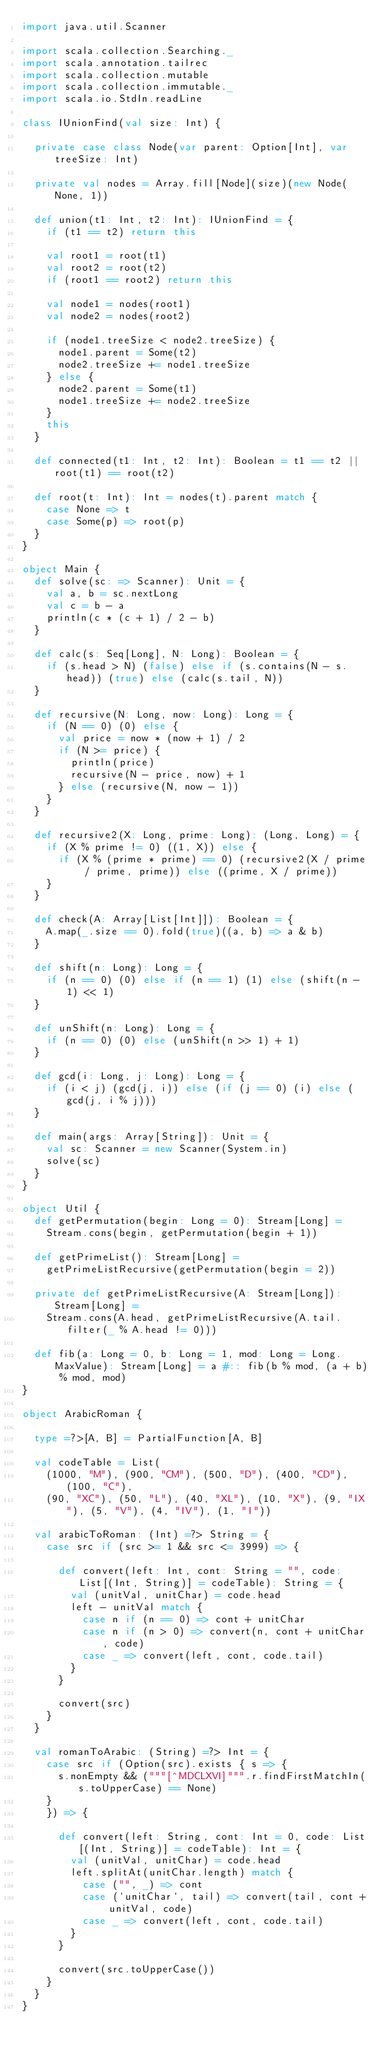<code> <loc_0><loc_0><loc_500><loc_500><_Scala_>import java.util.Scanner

import scala.collection.Searching._
import scala.annotation.tailrec
import scala.collection.mutable
import scala.collection.immutable._
import scala.io.StdIn.readLine

class IUnionFind(val size: Int) {

  private case class Node(var parent: Option[Int], var treeSize: Int)

  private val nodes = Array.fill[Node](size)(new Node(None, 1))

  def union(t1: Int, t2: Int): IUnionFind = {
    if (t1 == t2) return this

    val root1 = root(t1)
    val root2 = root(t2)
    if (root1 == root2) return this

    val node1 = nodes(root1)
    val node2 = nodes(root2)

    if (node1.treeSize < node2.treeSize) {
      node1.parent = Some(t2)
      node2.treeSize += node1.treeSize
    } else {
      node2.parent = Some(t1)
      node1.treeSize += node2.treeSize
    }
    this
  }

  def connected(t1: Int, t2: Int): Boolean = t1 == t2 || root(t1) == root(t2)

  def root(t: Int): Int = nodes(t).parent match {
    case None => t
    case Some(p) => root(p)
  }
}

object Main {
  def solve(sc: => Scanner): Unit = {
    val a, b = sc.nextLong
    val c = b - a
    println(c * (c + 1) / 2 - b)
  }

  def calc(s: Seq[Long], N: Long): Boolean = {
    if (s.head > N) (false) else if (s.contains(N - s.head)) (true) else (calc(s.tail, N))
  }

  def recursive(N: Long, now: Long): Long = {
    if (N == 0) (0) else {
      val price = now * (now + 1) / 2
      if (N >= price) {
        println(price)
        recursive(N - price, now) + 1
      } else (recursive(N, now - 1))
    }
  }

  def recursive2(X: Long, prime: Long): (Long, Long) = {
    if (X % prime != 0) ((1, X)) else {
      if (X % (prime * prime) == 0) (recursive2(X / prime / prime, prime)) else ((prime, X / prime))
    }
  }

  def check(A: Array[List[Int]]): Boolean = {
    A.map(_.size == 0).fold(true)((a, b) => a & b)
  }

  def shift(n: Long): Long = {
    if (n == 0) (0) else if (n == 1) (1) else (shift(n - 1) << 1)
  }

  def unShift(n: Long): Long = {
    if (n == 0) (0) else (unShift(n >> 1) + 1)
  }

  def gcd(i: Long, j: Long): Long = {
    if (i < j) (gcd(j, i)) else (if (j == 0) (i) else (gcd(j, i % j)))
  }

  def main(args: Array[String]): Unit = {
    val sc: Scanner = new Scanner(System.in)
    solve(sc)
  }
}

object Util {
  def getPermutation(begin: Long = 0): Stream[Long] =
    Stream.cons(begin, getPermutation(begin + 1))

  def getPrimeList(): Stream[Long] =
    getPrimeListRecursive(getPermutation(begin = 2))

  private def getPrimeListRecursive(A: Stream[Long]): Stream[Long] =
    Stream.cons(A.head, getPrimeListRecursive(A.tail.filter(_ % A.head != 0)))

  def fib(a: Long = 0, b: Long = 1, mod: Long = Long.MaxValue): Stream[Long] = a #:: fib(b % mod, (a + b) % mod, mod)
}

object ArabicRoman {

  type =?>[A, B] = PartialFunction[A, B]

  val codeTable = List(
    (1000, "M"), (900, "CM"), (500, "D"), (400, "CD"), (100, "C"),
    (90, "XC"), (50, "L"), (40, "XL"), (10, "X"), (9, "IX"), (5, "V"), (4, "IV"), (1, "I"))

  val arabicToRoman: (Int) =?> String = {
    case src if (src >= 1 && src <= 3999) => {

      def convert(left: Int, cont: String = "", code: List[(Int, String)] = codeTable): String = {
        val (unitVal, unitChar) = code.head
        left - unitVal match {
          case n if (n == 0) => cont + unitChar
          case n if (n > 0) => convert(n, cont + unitChar, code)
          case _ => convert(left, cont, code.tail)
        }
      }

      convert(src)
    }
  }

  val romanToArabic: (String) =?> Int = {
    case src if (Option(src).exists { s => {
      s.nonEmpty && ("""[^MDCLXVI]""".r.findFirstMatchIn(s.toUpperCase) == None)
    }
    }) => {

      def convert(left: String, cont: Int = 0, code: List[(Int, String)] = codeTable): Int = {
        val (unitVal, unitChar) = code.head
        left.splitAt(unitChar.length) match {
          case ("", _) => cont
          case (`unitChar`, tail) => convert(tail, cont + unitVal, code)
          case _ => convert(left, cont, code.tail)
        }
      }

      convert(src.toUpperCase())
    }
  }
}</code> 